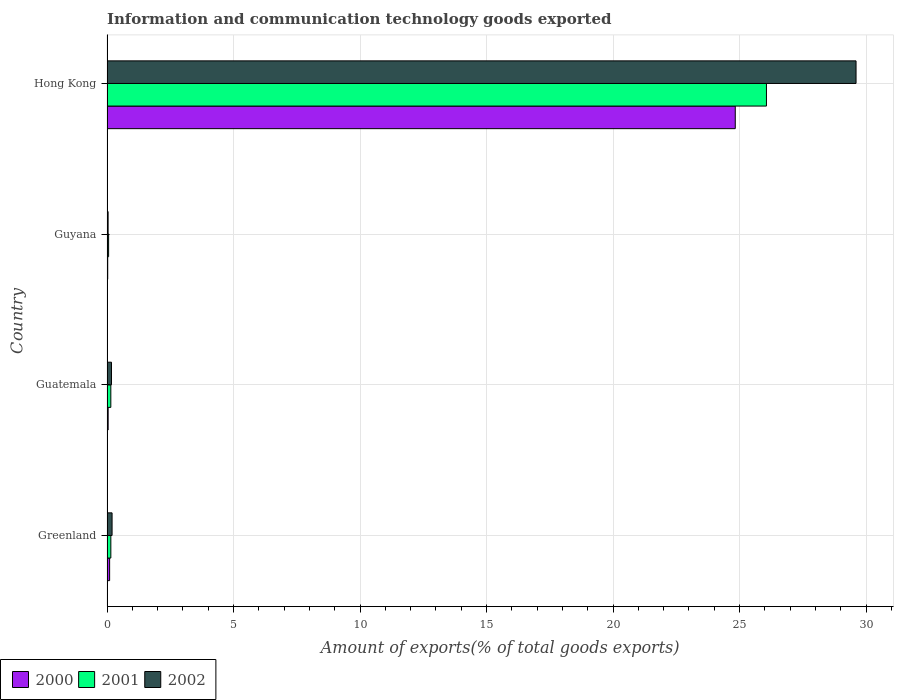How many different coloured bars are there?
Offer a terse response. 3. How many bars are there on the 4th tick from the top?
Keep it short and to the point. 3. How many bars are there on the 2nd tick from the bottom?
Provide a short and direct response. 3. What is the label of the 1st group of bars from the top?
Keep it short and to the point. Hong Kong. In how many cases, is the number of bars for a given country not equal to the number of legend labels?
Make the answer very short. 0. What is the amount of goods exported in 2002 in Hong Kong?
Give a very brief answer. 29.61. Across all countries, what is the maximum amount of goods exported in 2001?
Make the answer very short. 26.07. Across all countries, what is the minimum amount of goods exported in 2001?
Make the answer very short. 0.06. In which country was the amount of goods exported in 2002 maximum?
Your answer should be very brief. Hong Kong. In which country was the amount of goods exported in 2001 minimum?
Keep it short and to the point. Guyana. What is the total amount of goods exported in 2000 in the graph?
Provide a succinct answer. 25.01. What is the difference between the amount of goods exported in 2001 in Guatemala and that in Hong Kong?
Ensure brevity in your answer.  -25.91. What is the difference between the amount of goods exported in 2002 in Greenland and the amount of goods exported in 2000 in Hong Kong?
Provide a succinct answer. -24.63. What is the average amount of goods exported in 2001 per country?
Your answer should be compact. 6.61. What is the difference between the amount of goods exported in 2001 and amount of goods exported in 2000 in Hong Kong?
Your answer should be compact. 1.23. In how many countries, is the amount of goods exported in 2002 greater than 7 %?
Make the answer very short. 1. What is the ratio of the amount of goods exported in 2002 in Greenland to that in Guyana?
Make the answer very short. 4.56. Is the amount of goods exported in 2001 in Guatemala less than that in Guyana?
Provide a succinct answer. No. What is the difference between the highest and the second highest amount of goods exported in 2000?
Your response must be concise. 24.73. What is the difference between the highest and the lowest amount of goods exported in 2001?
Your answer should be compact. 26. What does the 1st bar from the top in Greenland represents?
Make the answer very short. 2002. Are the values on the major ticks of X-axis written in scientific E-notation?
Provide a short and direct response. No. Where does the legend appear in the graph?
Make the answer very short. Bottom left. How many legend labels are there?
Your answer should be very brief. 3. What is the title of the graph?
Your response must be concise. Information and communication technology goods exported. What is the label or title of the X-axis?
Ensure brevity in your answer.  Amount of exports(% of total goods exports). What is the label or title of the Y-axis?
Make the answer very short. Country. What is the Amount of exports(% of total goods exports) in 2000 in Greenland?
Provide a short and direct response. 0.1. What is the Amount of exports(% of total goods exports) in 2001 in Greenland?
Give a very brief answer. 0.15. What is the Amount of exports(% of total goods exports) in 2002 in Greenland?
Provide a succinct answer. 0.2. What is the Amount of exports(% of total goods exports) in 2000 in Guatemala?
Your answer should be very brief. 0.05. What is the Amount of exports(% of total goods exports) in 2001 in Guatemala?
Provide a short and direct response. 0.15. What is the Amount of exports(% of total goods exports) of 2002 in Guatemala?
Make the answer very short. 0.18. What is the Amount of exports(% of total goods exports) in 2000 in Guyana?
Keep it short and to the point. 0.03. What is the Amount of exports(% of total goods exports) in 2001 in Guyana?
Provide a succinct answer. 0.06. What is the Amount of exports(% of total goods exports) of 2002 in Guyana?
Your response must be concise. 0.04. What is the Amount of exports(% of total goods exports) of 2000 in Hong Kong?
Provide a short and direct response. 24.83. What is the Amount of exports(% of total goods exports) in 2001 in Hong Kong?
Your answer should be compact. 26.07. What is the Amount of exports(% of total goods exports) of 2002 in Hong Kong?
Offer a terse response. 29.61. Across all countries, what is the maximum Amount of exports(% of total goods exports) in 2000?
Your response must be concise. 24.83. Across all countries, what is the maximum Amount of exports(% of total goods exports) in 2001?
Offer a very short reply. 26.07. Across all countries, what is the maximum Amount of exports(% of total goods exports) in 2002?
Offer a terse response. 29.61. Across all countries, what is the minimum Amount of exports(% of total goods exports) of 2000?
Provide a succinct answer. 0.03. Across all countries, what is the minimum Amount of exports(% of total goods exports) of 2001?
Give a very brief answer. 0.06. Across all countries, what is the minimum Amount of exports(% of total goods exports) in 2002?
Provide a short and direct response. 0.04. What is the total Amount of exports(% of total goods exports) in 2000 in the graph?
Provide a succinct answer. 25.01. What is the total Amount of exports(% of total goods exports) of 2001 in the graph?
Give a very brief answer. 26.43. What is the total Amount of exports(% of total goods exports) in 2002 in the graph?
Your answer should be compact. 30.03. What is the difference between the Amount of exports(% of total goods exports) of 2000 in Greenland and that in Guatemala?
Offer a very short reply. 0.06. What is the difference between the Amount of exports(% of total goods exports) in 2001 in Greenland and that in Guatemala?
Ensure brevity in your answer.  0. What is the difference between the Amount of exports(% of total goods exports) of 2002 in Greenland and that in Guatemala?
Keep it short and to the point. 0.02. What is the difference between the Amount of exports(% of total goods exports) of 2000 in Greenland and that in Guyana?
Ensure brevity in your answer.  0.07. What is the difference between the Amount of exports(% of total goods exports) in 2001 in Greenland and that in Guyana?
Offer a very short reply. 0.09. What is the difference between the Amount of exports(% of total goods exports) of 2002 in Greenland and that in Guyana?
Offer a terse response. 0.16. What is the difference between the Amount of exports(% of total goods exports) of 2000 in Greenland and that in Hong Kong?
Your answer should be very brief. -24.73. What is the difference between the Amount of exports(% of total goods exports) in 2001 in Greenland and that in Hong Kong?
Your answer should be very brief. -25.91. What is the difference between the Amount of exports(% of total goods exports) of 2002 in Greenland and that in Hong Kong?
Keep it short and to the point. -29.41. What is the difference between the Amount of exports(% of total goods exports) of 2000 in Guatemala and that in Guyana?
Offer a terse response. 0.02. What is the difference between the Amount of exports(% of total goods exports) of 2001 in Guatemala and that in Guyana?
Ensure brevity in your answer.  0.09. What is the difference between the Amount of exports(% of total goods exports) in 2002 in Guatemala and that in Guyana?
Keep it short and to the point. 0.13. What is the difference between the Amount of exports(% of total goods exports) in 2000 in Guatemala and that in Hong Kong?
Give a very brief answer. -24.79. What is the difference between the Amount of exports(% of total goods exports) of 2001 in Guatemala and that in Hong Kong?
Your response must be concise. -25.91. What is the difference between the Amount of exports(% of total goods exports) of 2002 in Guatemala and that in Hong Kong?
Offer a very short reply. -29.43. What is the difference between the Amount of exports(% of total goods exports) in 2000 in Guyana and that in Hong Kong?
Your answer should be compact. -24.8. What is the difference between the Amount of exports(% of total goods exports) in 2001 in Guyana and that in Hong Kong?
Offer a very short reply. -26. What is the difference between the Amount of exports(% of total goods exports) in 2002 in Guyana and that in Hong Kong?
Make the answer very short. -29.56. What is the difference between the Amount of exports(% of total goods exports) in 2000 in Greenland and the Amount of exports(% of total goods exports) in 2001 in Guatemala?
Your response must be concise. -0.05. What is the difference between the Amount of exports(% of total goods exports) of 2000 in Greenland and the Amount of exports(% of total goods exports) of 2002 in Guatemala?
Provide a succinct answer. -0.07. What is the difference between the Amount of exports(% of total goods exports) of 2001 in Greenland and the Amount of exports(% of total goods exports) of 2002 in Guatemala?
Your answer should be compact. -0.02. What is the difference between the Amount of exports(% of total goods exports) in 2000 in Greenland and the Amount of exports(% of total goods exports) in 2001 in Guyana?
Offer a terse response. 0.04. What is the difference between the Amount of exports(% of total goods exports) in 2000 in Greenland and the Amount of exports(% of total goods exports) in 2002 in Guyana?
Ensure brevity in your answer.  0.06. What is the difference between the Amount of exports(% of total goods exports) of 2001 in Greenland and the Amount of exports(% of total goods exports) of 2002 in Guyana?
Your response must be concise. 0.11. What is the difference between the Amount of exports(% of total goods exports) of 2000 in Greenland and the Amount of exports(% of total goods exports) of 2001 in Hong Kong?
Your response must be concise. -25.96. What is the difference between the Amount of exports(% of total goods exports) in 2000 in Greenland and the Amount of exports(% of total goods exports) in 2002 in Hong Kong?
Your answer should be compact. -29.5. What is the difference between the Amount of exports(% of total goods exports) of 2001 in Greenland and the Amount of exports(% of total goods exports) of 2002 in Hong Kong?
Provide a short and direct response. -29.45. What is the difference between the Amount of exports(% of total goods exports) in 2000 in Guatemala and the Amount of exports(% of total goods exports) in 2001 in Guyana?
Your answer should be very brief. -0.02. What is the difference between the Amount of exports(% of total goods exports) in 2000 in Guatemala and the Amount of exports(% of total goods exports) in 2002 in Guyana?
Make the answer very short. 0. What is the difference between the Amount of exports(% of total goods exports) of 2001 in Guatemala and the Amount of exports(% of total goods exports) of 2002 in Guyana?
Provide a succinct answer. 0.11. What is the difference between the Amount of exports(% of total goods exports) of 2000 in Guatemala and the Amount of exports(% of total goods exports) of 2001 in Hong Kong?
Offer a very short reply. -26.02. What is the difference between the Amount of exports(% of total goods exports) in 2000 in Guatemala and the Amount of exports(% of total goods exports) in 2002 in Hong Kong?
Give a very brief answer. -29.56. What is the difference between the Amount of exports(% of total goods exports) in 2001 in Guatemala and the Amount of exports(% of total goods exports) in 2002 in Hong Kong?
Your answer should be very brief. -29.46. What is the difference between the Amount of exports(% of total goods exports) in 2000 in Guyana and the Amount of exports(% of total goods exports) in 2001 in Hong Kong?
Offer a very short reply. -26.04. What is the difference between the Amount of exports(% of total goods exports) of 2000 in Guyana and the Amount of exports(% of total goods exports) of 2002 in Hong Kong?
Offer a terse response. -29.58. What is the difference between the Amount of exports(% of total goods exports) in 2001 in Guyana and the Amount of exports(% of total goods exports) in 2002 in Hong Kong?
Give a very brief answer. -29.54. What is the average Amount of exports(% of total goods exports) of 2000 per country?
Your answer should be compact. 6.25. What is the average Amount of exports(% of total goods exports) of 2001 per country?
Provide a succinct answer. 6.61. What is the average Amount of exports(% of total goods exports) of 2002 per country?
Offer a very short reply. 7.51. What is the difference between the Amount of exports(% of total goods exports) of 2000 and Amount of exports(% of total goods exports) of 2001 in Greenland?
Your response must be concise. -0.05. What is the difference between the Amount of exports(% of total goods exports) of 2000 and Amount of exports(% of total goods exports) of 2002 in Greenland?
Offer a terse response. -0.1. What is the difference between the Amount of exports(% of total goods exports) of 2001 and Amount of exports(% of total goods exports) of 2002 in Greenland?
Provide a short and direct response. -0.05. What is the difference between the Amount of exports(% of total goods exports) in 2000 and Amount of exports(% of total goods exports) in 2001 in Guatemala?
Your answer should be very brief. -0.11. What is the difference between the Amount of exports(% of total goods exports) in 2000 and Amount of exports(% of total goods exports) in 2002 in Guatemala?
Make the answer very short. -0.13. What is the difference between the Amount of exports(% of total goods exports) of 2001 and Amount of exports(% of total goods exports) of 2002 in Guatemala?
Offer a terse response. -0.03. What is the difference between the Amount of exports(% of total goods exports) of 2000 and Amount of exports(% of total goods exports) of 2001 in Guyana?
Provide a succinct answer. -0.03. What is the difference between the Amount of exports(% of total goods exports) of 2000 and Amount of exports(% of total goods exports) of 2002 in Guyana?
Give a very brief answer. -0.02. What is the difference between the Amount of exports(% of total goods exports) in 2001 and Amount of exports(% of total goods exports) in 2002 in Guyana?
Make the answer very short. 0.02. What is the difference between the Amount of exports(% of total goods exports) of 2000 and Amount of exports(% of total goods exports) of 2001 in Hong Kong?
Offer a very short reply. -1.23. What is the difference between the Amount of exports(% of total goods exports) in 2000 and Amount of exports(% of total goods exports) in 2002 in Hong Kong?
Your answer should be very brief. -4.77. What is the difference between the Amount of exports(% of total goods exports) in 2001 and Amount of exports(% of total goods exports) in 2002 in Hong Kong?
Your response must be concise. -3.54. What is the ratio of the Amount of exports(% of total goods exports) in 2000 in Greenland to that in Guatemala?
Your answer should be very brief. 2.27. What is the ratio of the Amount of exports(% of total goods exports) of 2002 in Greenland to that in Guatemala?
Provide a succinct answer. 1.13. What is the ratio of the Amount of exports(% of total goods exports) in 2000 in Greenland to that in Guyana?
Your response must be concise. 3.63. What is the ratio of the Amount of exports(% of total goods exports) of 2001 in Greenland to that in Guyana?
Your answer should be compact. 2.4. What is the ratio of the Amount of exports(% of total goods exports) in 2002 in Greenland to that in Guyana?
Your answer should be compact. 4.56. What is the ratio of the Amount of exports(% of total goods exports) in 2000 in Greenland to that in Hong Kong?
Provide a short and direct response. 0. What is the ratio of the Amount of exports(% of total goods exports) of 2001 in Greenland to that in Hong Kong?
Make the answer very short. 0.01. What is the ratio of the Amount of exports(% of total goods exports) in 2002 in Greenland to that in Hong Kong?
Offer a terse response. 0.01. What is the ratio of the Amount of exports(% of total goods exports) in 2000 in Guatemala to that in Guyana?
Your answer should be compact. 1.6. What is the ratio of the Amount of exports(% of total goods exports) of 2001 in Guatemala to that in Guyana?
Provide a short and direct response. 2.39. What is the ratio of the Amount of exports(% of total goods exports) of 2002 in Guatemala to that in Guyana?
Your answer should be very brief. 4.02. What is the ratio of the Amount of exports(% of total goods exports) in 2000 in Guatemala to that in Hong Kong?
Give a very brief answer. 0. What is the ratio of the Amount of exports(% of total goods exports) in 2001 in Guatemala to that in Hong Kong?
Ensure brevity in your answer.  0.01. What is the ratio of the Amount of exports(% of total goods exports) in 2002 in Guatemala to that in Hong Kong?
Your response must be concise. 0.01. What is the ratio of the Amount of exports(% of total goods exports) of 2000 in Guyana to that in Hong Kong?
Make the answer very short. 0. What is the ratio of the Amount of exports(% of total goods exports) in 2001 in Guyana to that in Hong Kong?
Your answer should be compact. 0. What is the ratio of the Amount of exports(% of total goods exports) in 2002 in Guyana to that in Hong Kong?
Offer a terse response. 0. What is the difference between the highest and the second highest Amount of exports(% of total goods exports) of 2000?
Your answer should be very brief. 24.73. What is the difference between the highest and the second highest Amount of exports(% of total goods exports) of 2001?
Offer a very short reply. 25.91. What is the difference between the highest and the second highest Amount of exports(% of total goods exports) of 2002?
Your response must be concise. 29.41. What is the difference between the highest and the lowest Amount of exports(% of total goods exports) of 2000?
Make the answer very short. 24.8. What is the difference between the highest and the lowest Amount of exports(% of total goods exports) of 2001?
Your answer should be compact. 26. What is the difference between the highest and the lowest Amount of exports(% of total goods exports) in 2002?
Your response must be concise. 29.56. 